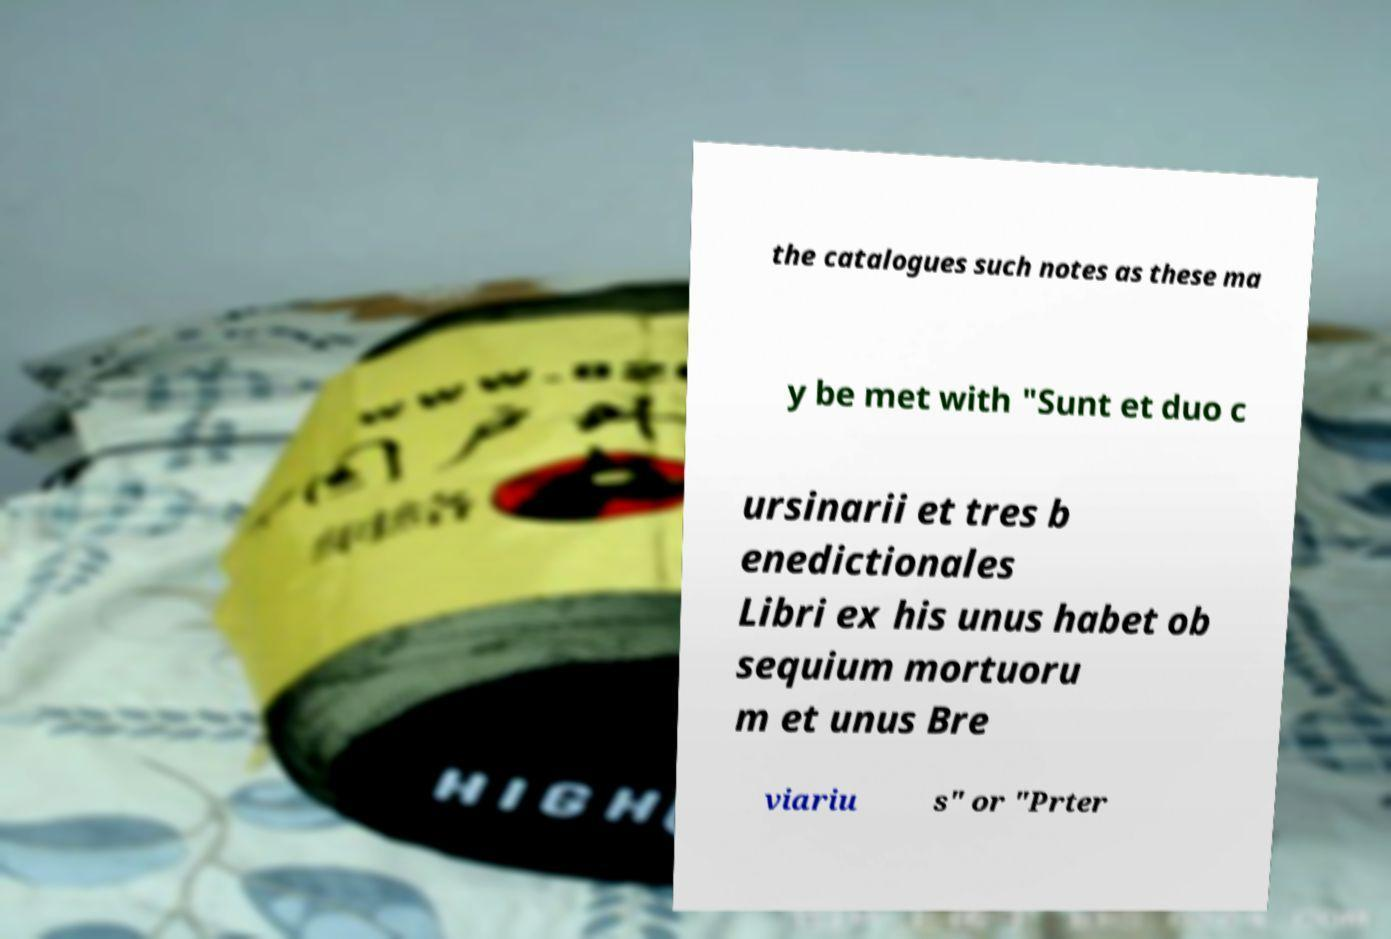I need the written content from this picture converted into text. Can you do that? the catalogues such notes as these ma y be met with "Sunt et duo c ursinarii et tres b enedictionales Libri ex his unus habet ob sequium mortuoru m et unus Bre viariu s" or "Prter 